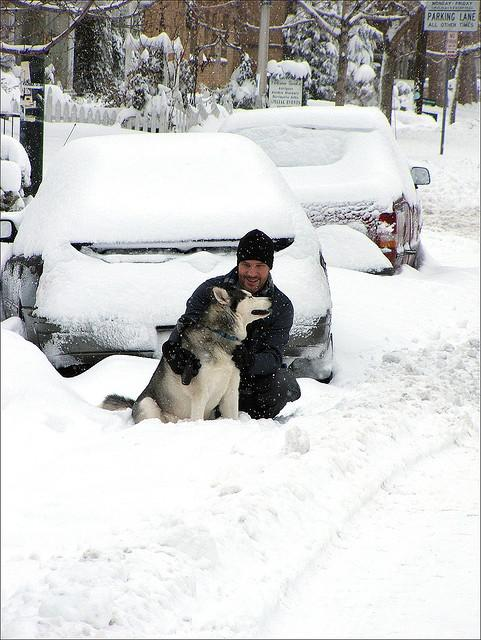This animal is the same species as what character on Game of Thrones? Please explain your reasoning. ghost. A dog is with a man. ghost on game of thrones was a wolf. 